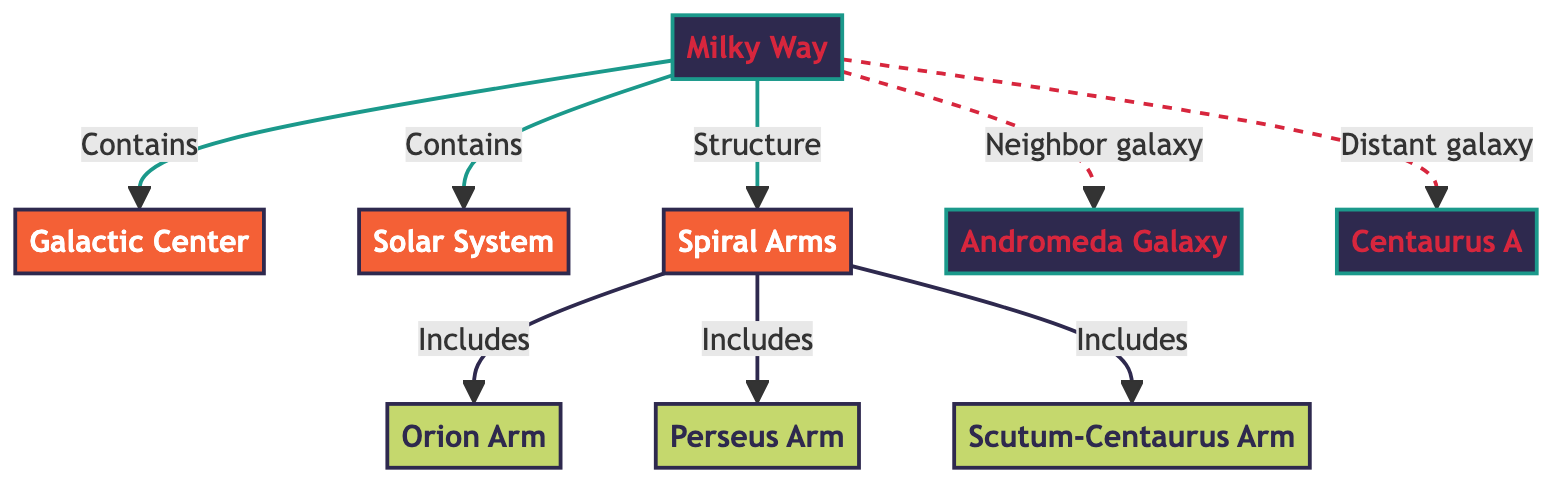What is the central structure of the Milky Way? The diagram identifies the "Galactic Center" as the main structure at the center of the Milky Way. This can be directly observed in the flowchart where the arrow from "Milky Way" points to "Galactic Center."
Answer: Galactic Center How many spiral arms are indicated in the diagram? The diagram displays three spiral arms: "Orion Arm," "Perseus Arm," and "Scutum-Centaurus Arm." Each of these is connected to the "Spiral Arms" node, which leads us to conclude that there are three distinct spiral arms mentioned.
Answer: 3 Which arm includes the Solar System? The diagram does not label any spiral arm as containing the Solar System directly, but it shows "Solar System" is part of the "Milky Way," which connects to "Spiral Arms." The "Orion Arm" is a known arm that includes our Solar System, so this context helps identify the arm.
Answer: Orion Arm What type of galaxies are designated as neighbors and distant to the Milky Way? The diagram points out "Andromeda Galaxy" as a neighbor galaxy and "Centaurus A" as a distant galaxy, distinguished by the different types of connections shown (solid line for neighbor and dashed line for distant).
Answer: Andromeda Galaxy, Centaurus A What does the Milky Way contain according to the diagram? The arrow from "Milky Way" leads to "Galactic Center" and "Solar System," indicating both are contents of the Milky Way. This suggests that these two structures are part of the Milky Way's composition.
Answer: Galactic Center, Solar System 